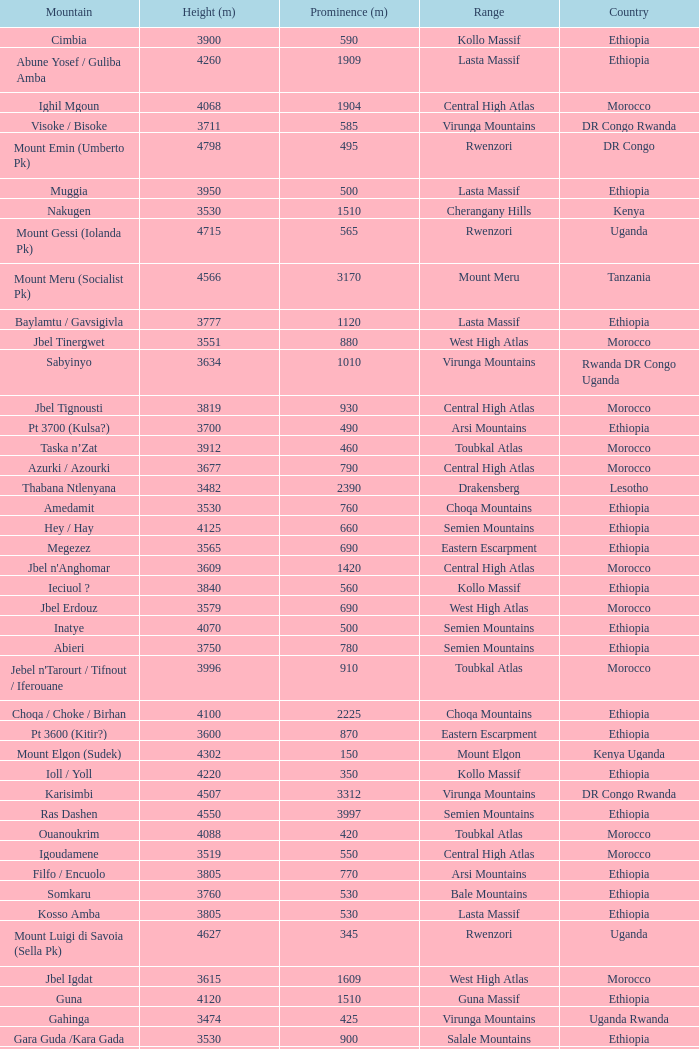How tall is the Mountain of jbel ghat? 1.0. 